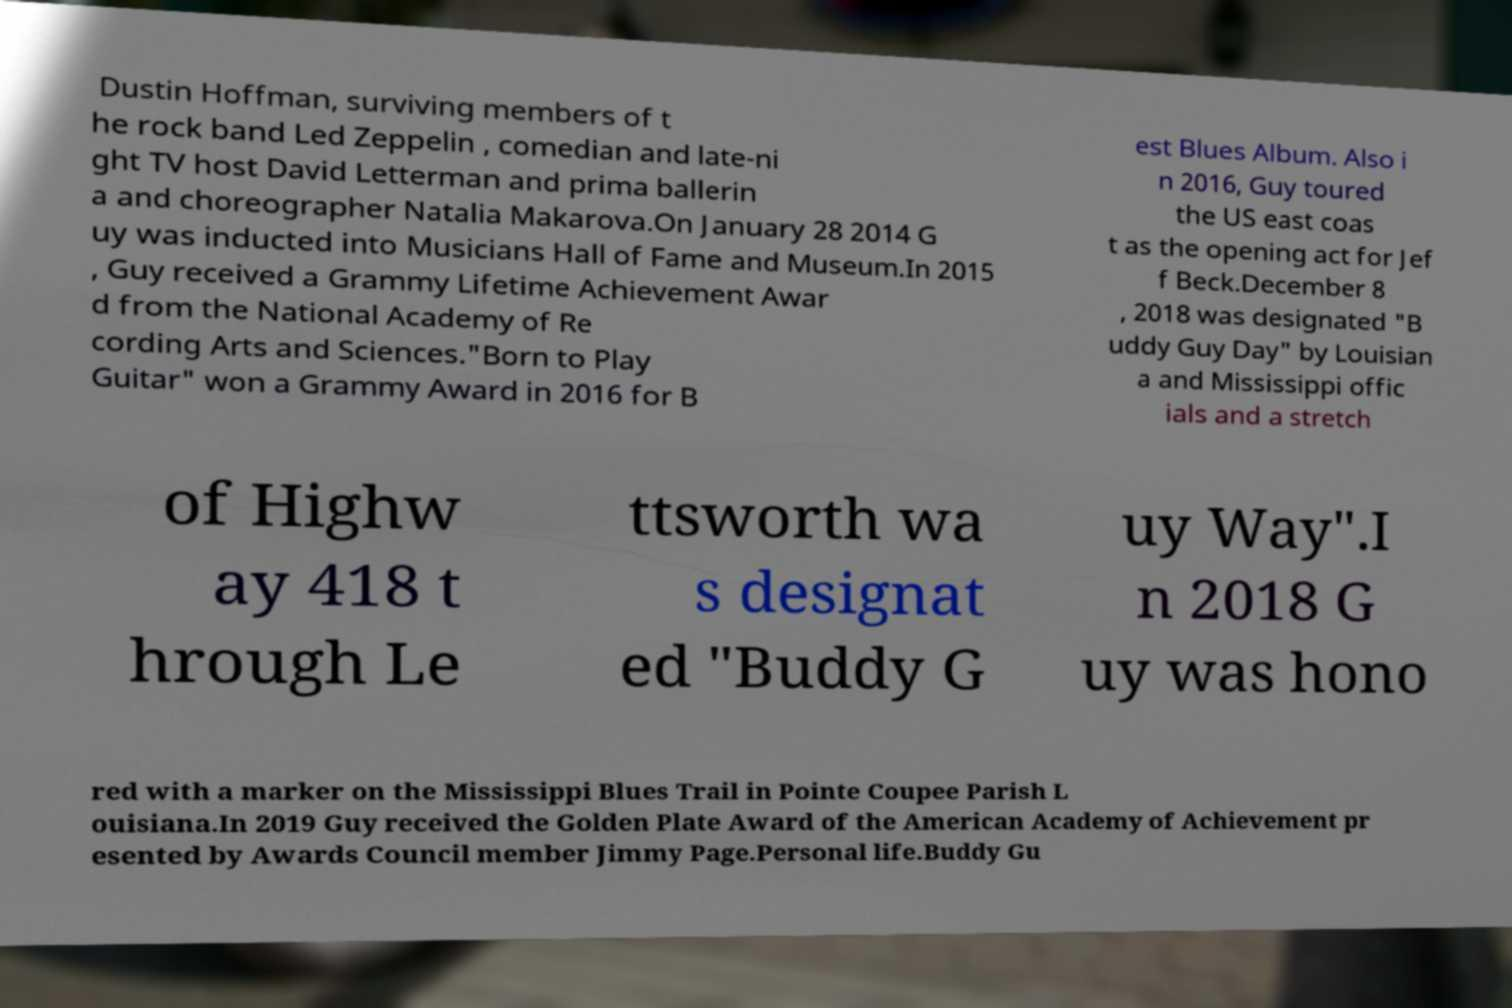What messages or text are displayed in this image? I need them in a readable, typed format. Dustin Hoffman, surviving members of t he rock band Led Zeppelin , comedian and late-ni ght TV host David Letterman and prima ballerin a and choreographer Natalia Makarova.On January 28 2014 G uy was inducted into Musicians Hall of Fame and Museum.In 2015 , Guy received a Grammy Lifetime Achievement Awar d from the National Academy of Re cording Arts and Sciences."Born to Play Guitar" won a Grammy Award in 2016 for B est Blues Album. Also i n 2016, Guy toured the US east coas t as the opening act for Jef f Beck.December 8 , 2018 was designated "B uddy Guy Day" by Louisian a and Mississippi offic ials and a stretch of Highw ay 418 t hrough Le ttsworth wa s designat ed "Buddy G uy Way".I n 2018 G uy was hono red with a marker on the Mississippi Blues Trail in Pointe Coupee Parish L ouisiana.In 2019 Guy received the Golden Plate Award of the American Academy of Achievement pr esented by Awards Council member Jimmy Page.Personal life.Buddy Gu 